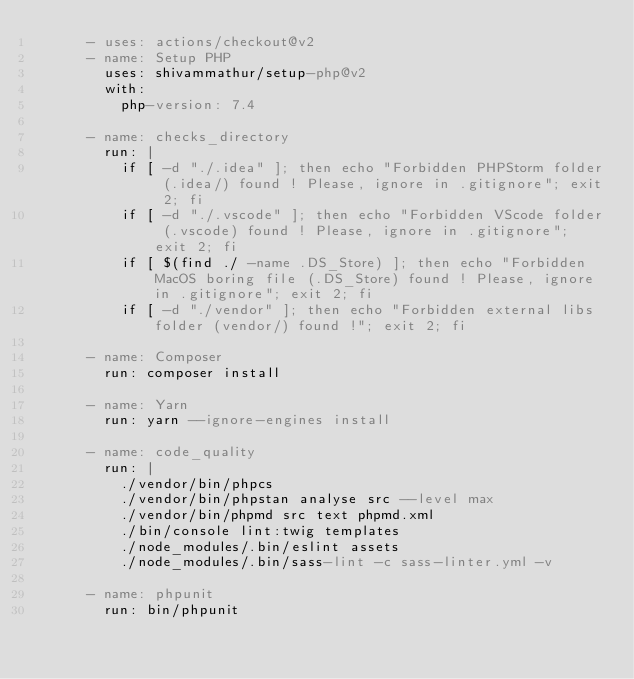<code> <loc_0><loc_0><loc_500><loc_500><_YAML_>      - uses: actions/checkout@v2
      - name: Setup PHP
        uses: shivammathur/setup-php@v2
        with:
          php-version: 7.4

      - name: checks_directory
        run: |
          if [ -d "./.idea" ]; then echo "Forbidden PHPStorm folder (.idea/) found ! Please, ignore in .gitignore"; exit 2; fi
          if [ -d "./.vscode" ]; then echo "Forbidden VScode folder (.vscode) found ! Please, ignore in .gitignore"; exit 2; fi
          if [ $(find ./ -name .DS_Store) ]; then echo "Forbidden MacOS boring file (.DS_Store) found ! Please, ignore in .gitignore"; exit 2; fi
          if [ -d "./vendor" ]; then echo "Forbidden external libs folder (vendor/) found !"; exit 2; fi

      - name: Composer
        run: composer install

      - name: Yarn
        run: yarn --ignore-engines install

      - name: code_quality
        run: |
          ./vendor/bin/phpcs
          ./vendor/bin/phpstan analyse src --level max
          ./vendor/bin/phpmd src text phpmd.xml
          ./bin/console lint:twig templates
          ./node_modules/.bin/eslint assets
          ./node_modules/.bin/sass-lint -c sass-linter.yml -v

      - name: phpunit
        run: bin/phpunit

</code> 